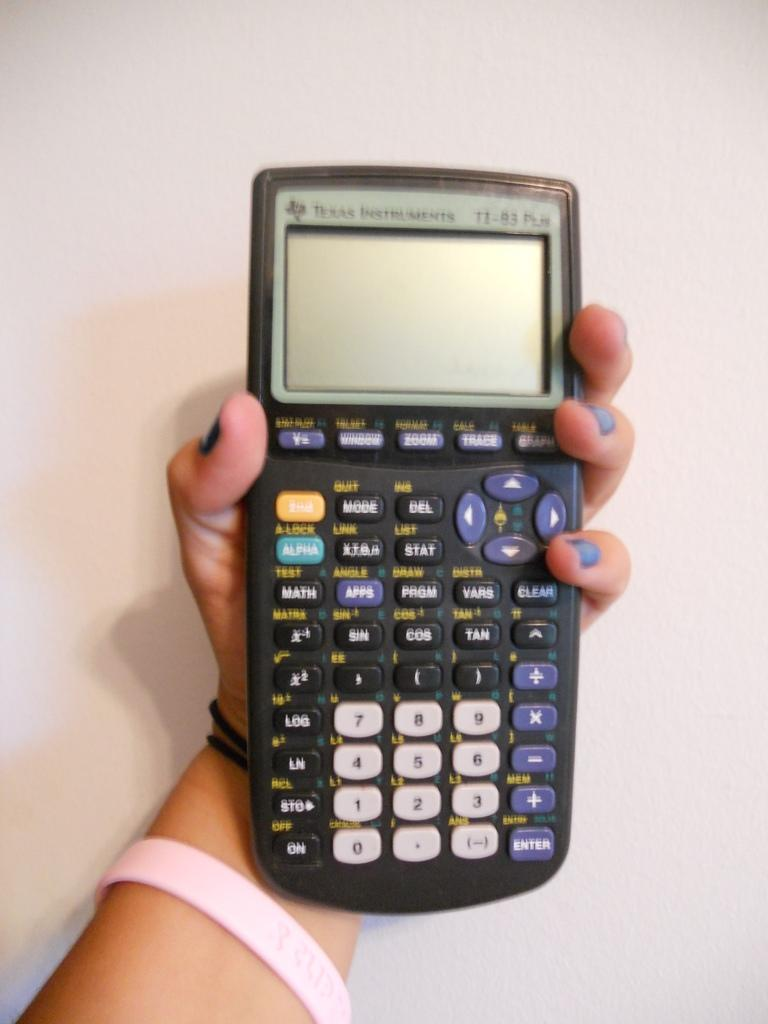<image>
Share a concise interpretation of the image provided. Someone holds up a Texas Instruments graphing calculator in front of a white wall. 